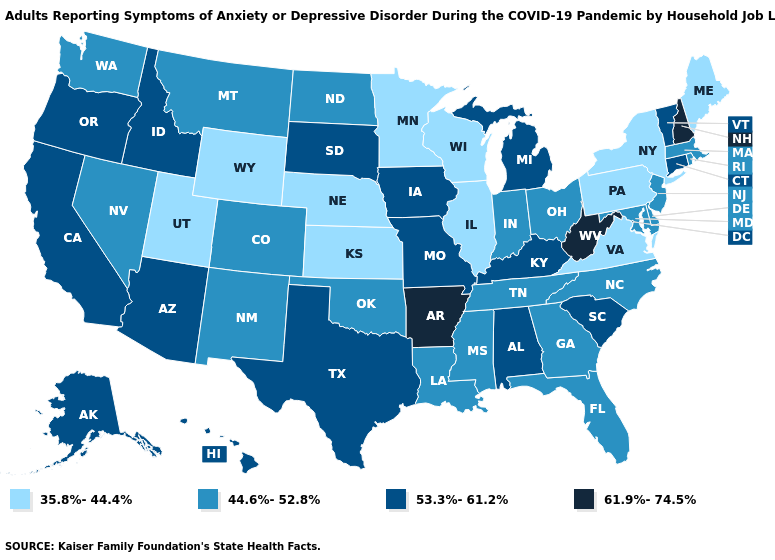Name the states that have a value in the range 35.8%-44.4%?
Be succinct. Illinois, Kansas, Maine, Minnesota, Nebraska, New York, Pennsylvania, Utah, Virginia, Wisconsin, Wyoming. Which states have the lowest value in the USA?
Keep it brief. Illinois, Kansas, Maine, Minnesota, Nebraska, New York, Pennsylvania, Utah, Virginia, Wisconsin, Wyoming. What is the value of Oregon?
Answer briefly. 53.3%-61.2%. Does Missouri have the lowest value in the MidWest?
Be succinct. No. Among the states that border Washington , which have the lowest value?
Concise answer only. Idaho, Oregon. Does the first symbol in the legend represent the smallest category?
Short answer required. Yes. What is the value of Maryland?
Concise answer only. 44.6%-52.8%. What is the value of Pennsylvania?
Short answer required. 35.8%-44.4%. What is the lowest value in the USA?
Quick response, please. 35.8%-44.4%. Does Louisiana have the same value as Maryland?
Concise answer only. Yes. Does West Virginia have the highest value in the South?
Be succinct. Yes. What is the lowest value in the USA?
Give a very brief answer. 35.8%-44.4%. Name the states that have a value in the range 53.3%-61.2%?
Write a very short answer. Alabama, Alaska, Arizona, California, Connecticut, Hawaii, Idaho, Iowa, Kentucky, Michigan, Missouri, Oregon, South Carolina, South Dakota, Texas, Vermont. What is the highest value in the MidWest ?
Answer briefly. 53.3%-61.2%. 